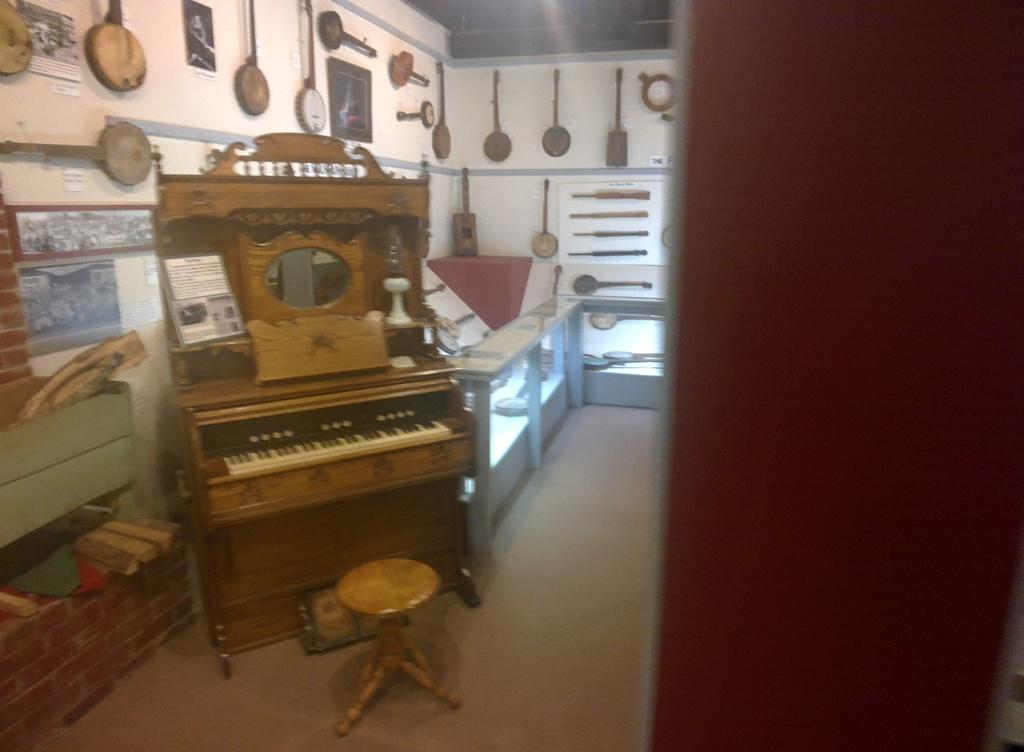What is the main object in the image? There is a piano in the image. What is placed near the piano? There is a stool in the image. What can be seen in the background of the image? There are musical instruments attached to the wall in the background of the image. What type of cherry is used as a decoration on the piano in the image? There is no cherry present as a decoration on the piano in the image. How does the beginner musician use the toothbrush in the image? There is no toothbrush present in the image, so it cannot be used by a musician. 